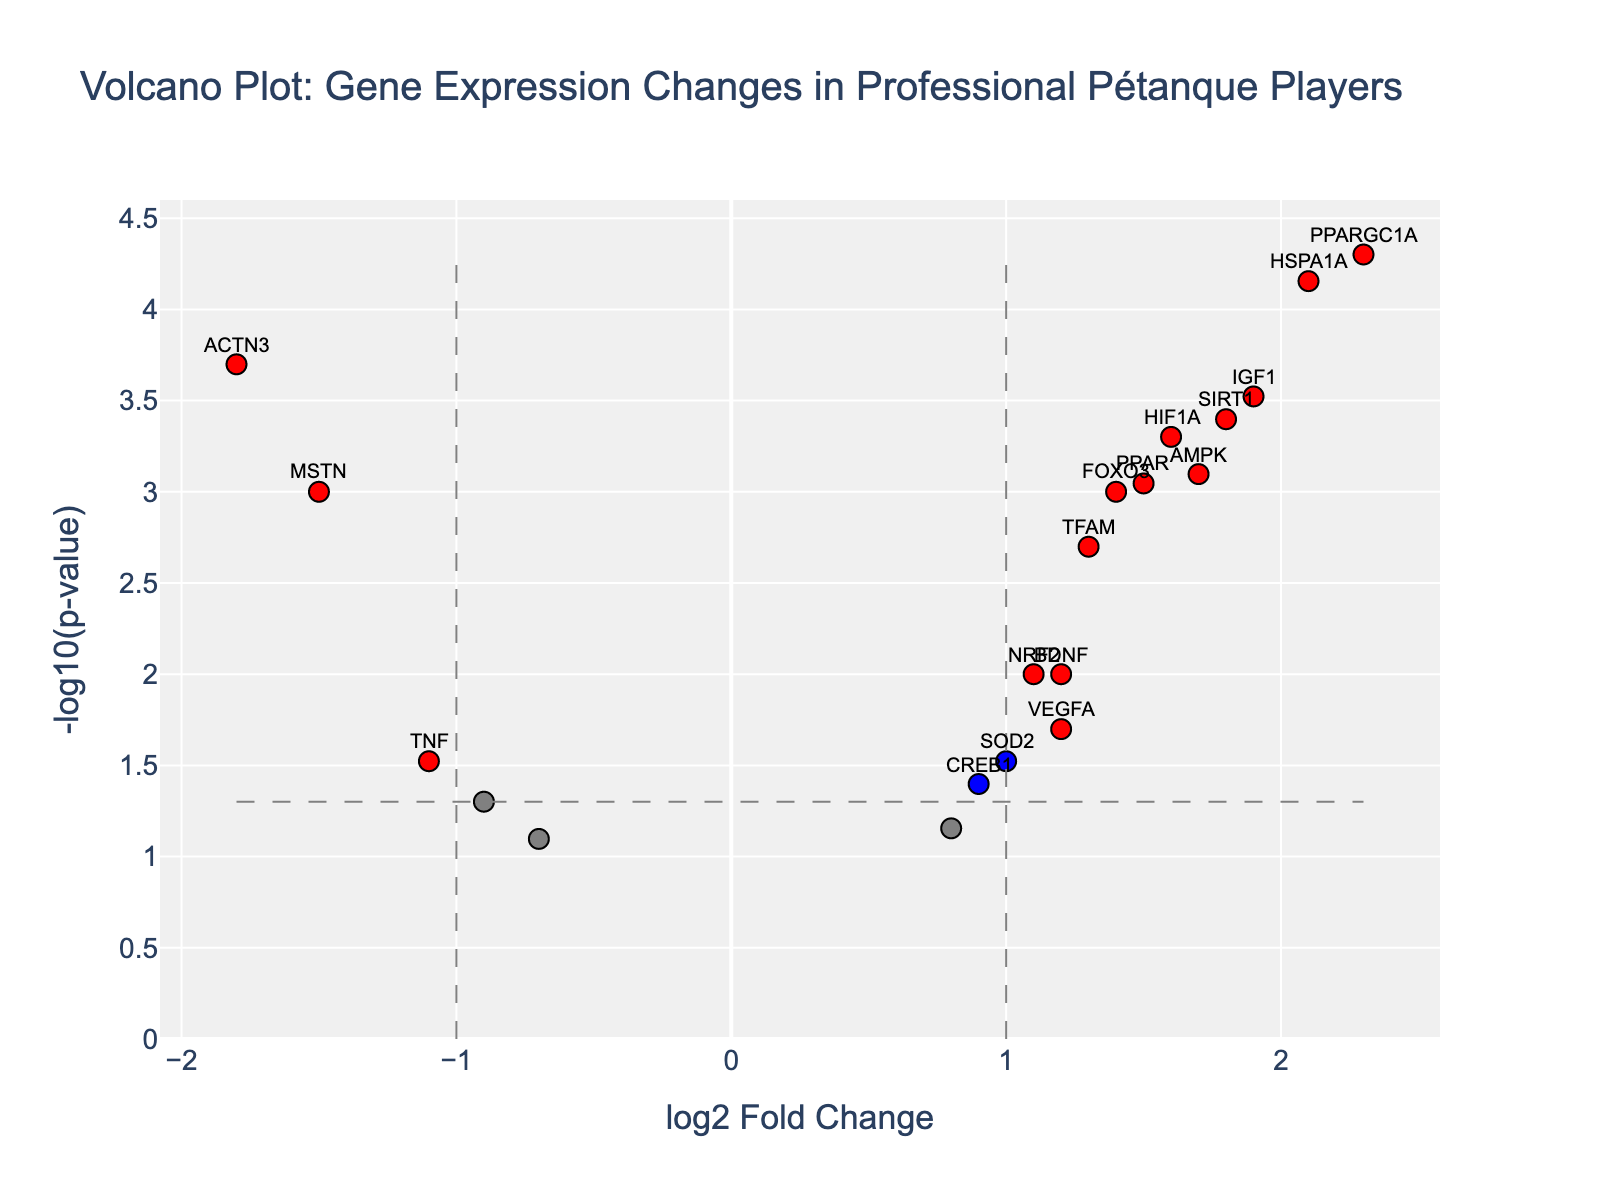How many genes were significantly upregulated in professional pétanque players? Look for red dots on the right side of the plot (positive log2 Fold Change) where the p-value is below 0.05, indicated by the dashed horizontal line (-log10(p-value) > 1.3). Count these dots.
Answer: 9 Which gene has the highest log2 Fold Change in professional pétanque players? Identify the gene with the largest value on the x-axis (positive side). The hover text should help confirm this gene.
Answer: PPARGC1A Between ACTN3 and MSTN, which gene is more downregulated in professional pétanque players? Both genes are located on the negative x-axis (log2 Fold Change < 0). Compare their log2 Fold Change values and identify which one is more negative.
Answer: ACTN3 What is the significance threshold for the p-value in this plot? The threshold is indicated by a horizontal dashed line, where all points above this line are significant. The y-axis value related to this line is mentioned.
Answer: 0.05 How many genes have a positive log2 Fold Change but are not significant? Find blue or gray dots on the positive side of the x-axis (log2 Fold Change > 0) that lie below the horizontal threshold line (-log10(p-value) < 1.3). Count these dots.
Answer: 2 Which gene is the most significantly upregulated, considering both the p-value and log2 Fold Change? Look for the gene on the plot with the highest combination of -log10(p-value) and log2 Fold Change values, and confirm it using the hover text.
Answer: PPARGC1A Are more genes upregulated or downregulated significantly? Count the red dots on both the positive and negative sides of the x-axis for the significant genes (considering the threshold lines). Compare the counts.
Answer: More upregulated What’s the log2 Fold Change of the gene with the smallest p-value? The smallest p-value should be the highest value on the y-axis. Check the hover text for the gene located at the topmost point on the y-axis.
Answer: 2.3 (PPARGC1A) How many genes have a log2 Fold Change between -1 and 1 and are significant? Look between -1 and 1 on the x-axis and above the horizontal threshold line (significant), and count these dots.
Answer: 4 